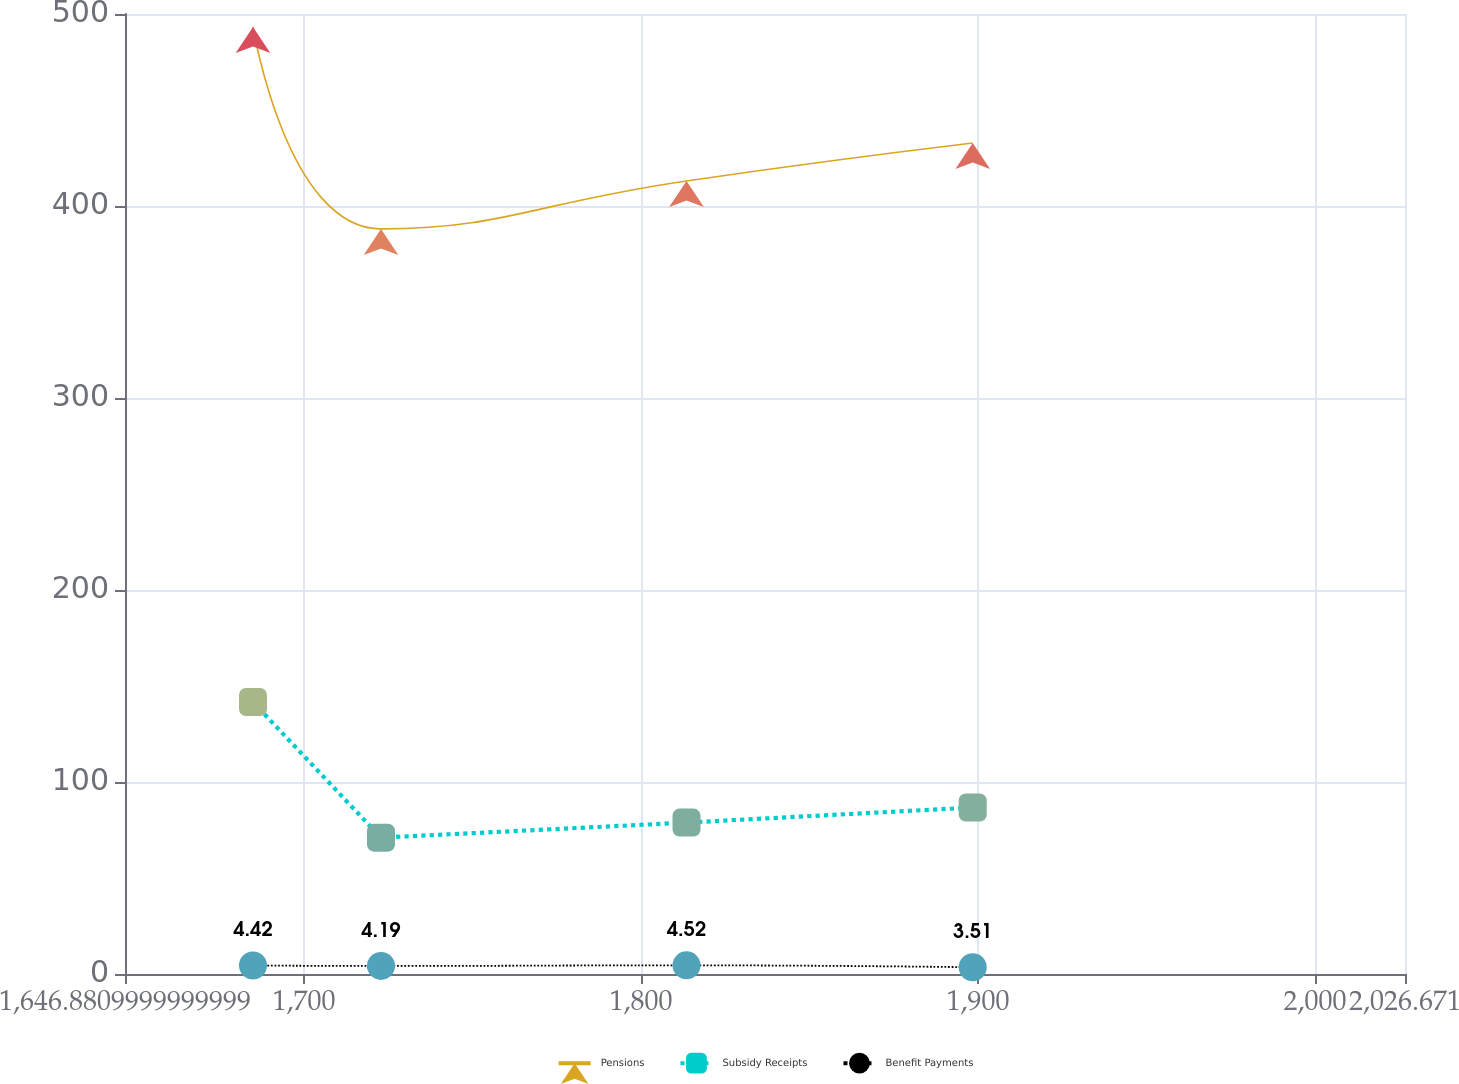Convert chart. <chart><loc_0><loc_0><loc_500><loc_500><line_chart><ecel><fcel>Pensions<fcel>Subsidy Receipts<fcel>Benefit Payments<nl><fcel>1684.86<fcel>493.26<fcel>141.65<fcel>4.42<nl><fcel>1722.84<fcel>388.06<fcel>71.01<fcel>4.19<nl><fcel>1813.49<fcel>413.05<fcel>78.86<fcel>4.52<nl><fcel>1898.41<fcel>432.81<fcel>86.71<fcel>3.51<nl><fcel>2064.65<fcel>449.87<fcel>63.16<fcel>3.97<nl></chart> 